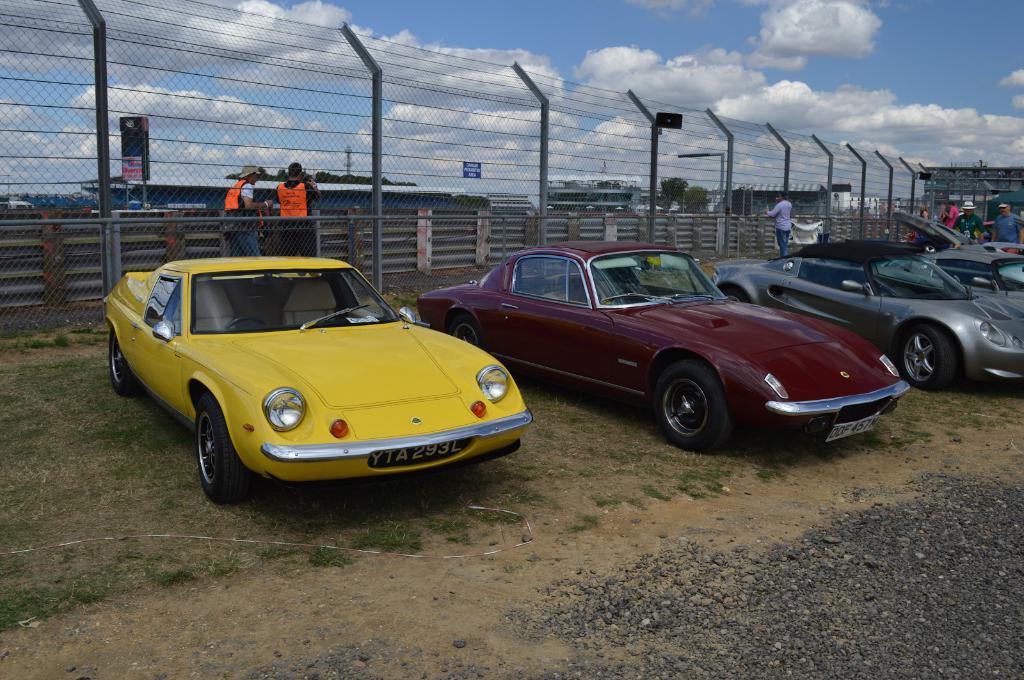Please provide a concise description of this image. the picture is taken in a parking lot. In the foreground of the picture there are cars, grass, stones and soil. In the center of the picture there are people standing and there is fencing, beside the fencing there are trees and building. Sky is cloudy. 